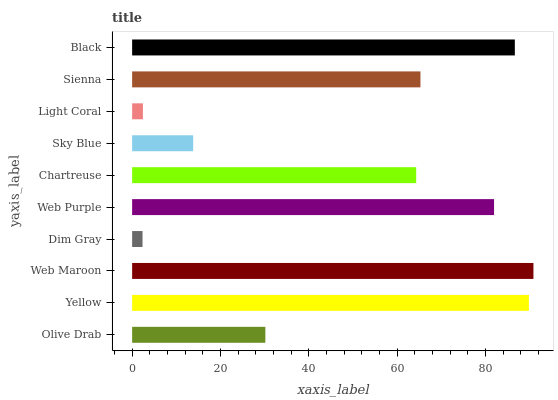Is Dim Gray the minimum?
Answer yes or no. Yes. Is Web Maroon the maximum?
Answer yes or no. Yes. Is Yellow the minimum?
Answer yes or no. No. Is Yellow the maximum?
Answer yes or no. No. Is Yellow greater than Olive Drab?
Answer yes or no. Yes. Is Olive Drab less than Yellow?
Answer yes or no. Yes. Is Olive Drab greater than Yellow?
Answer yes or no. No. Is Yellow less than Olive Drab?
Answer yes or no. No. Is Sienna the high median?
Answer yes or no. Yes. Is Chartreuse the low median?
Answer yes or no. Yes. Is Black the high median?
Answer yes or no. No. Is Web Maroon the low median?
Answer yes or no. No. 